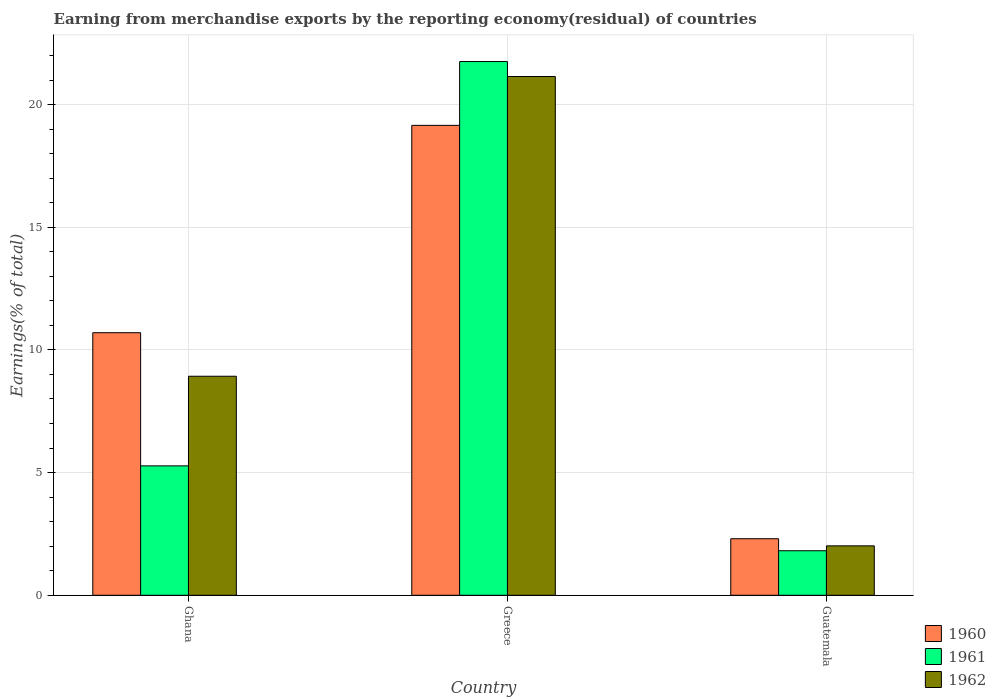How many different coloured bars are there?
Your answer should be very brief. 3. How many groups of bars are there?
Your answer should be compact. 3. Are the number of bars on each tick of the X-axis equal?
Ensure brevity in your answer.  Yes. How many bars are there on the 2nd tick from the left?
Your response must be concise. 3. How many bars are there on the 2nd tick from the right?
Provide a succinct answer. 3. What is the label of the 3rd group of bars from the left?
Your response must be concise. Guatemala. What is the percentage of amount earned from merchandise exports in 1960 in Guatemala?
Keep it short and to the point. 2.3. Across all countries, what is the maximum percentage of amount earned from merchandise exports in 1962?
Offer a very short reply. 21.14. Across all countries, what is the minimum percentage of amount earned from merchandise exports in 1962?
Ensure brevity in your answer.  2.01. In which country was the percentage of amount earned from merchandise exports in 1960 maximum?
Make the answer very short. Greece. In which country was the percentage of amount earned from merchandise exports in 1960 minimum?
Provide a succinct answer. Guatemala. What is the total percentage of amount earned from merchandise exports in 1961 in the graph?
Your response must be concise. 28.84. What is the difference between the percentage of amount earned from merchandise exports in 1961 in Ghana and that in Guatemala?
Give a very brief answer. 3.46. What is the difference between the percentage of amount earned from merchandise exports in 1961 in Ghana and the percentage of amount earned from merchandise exports in 1962 in Guatemala?
Your response must be concise. 3.26. What is the average percentage of amount earned from merchandise exports in 1962 per country?
Provide a short and direct response. 10.7. What is the difference between the percentage of amount earned from merchandise exports of/in 1962 and percentage of amount earned from merchandise exports of/in 1961 in Ghana?
Offer a very short reply. 3.65. In how many countries, is the percentage of amount earned from merchandise exports in 1961 greater than 9 %?
Provide a short and direct response. 1. What is the ratio of the percentage of amount earned from merchandise exports in 1960 in Ghana to that in Guatemala?
Offer a very short reply. 4.64. What is the difference between the highest and the second highest percentage of amount earned from merchandise exports in 1960?
Offer a terse response. -8.45. What is the difference between the highest and the lowest percentage of amount earned from merchandise exports in 1960?
Your answer should be very brief. 16.85. Is the sum of the percentage of amount earned from merchandise exports in 1961 in Ghana and Guatemala greater than the maximum percentage of amount earned from merchandise exports in 1962 across all countries?
Your answer should be very brief. No. What does the 3rd bar from the left in Ghana represents?
Provide a succinct answer. 1962. Is it the case that in every country, the sum of the percentage of amount earned from merchandise exports in 1962 and percentage of amount earned from merchandise exports in 1961 is greater than the percentage of amount earned from merchandise exports in 1960?
Offer a terse response. Yes. How many bars are there?
Your answer should be very brief. 9. What is the difference between two consecutive major ticks on the Y-axis?
Make the answer very short. 5. Are the values on the major ticks of Y-axis written in scientific E-notation?
Provide a succinct answer. No. Does the graph contain any zero values?
Provide a short and direct response. No. Where does the legend appear in the graph?
Provide a succinct answer. Bottom right. What is the title of the graph?
Offer a very short reply. Earning from merchandise exports by the reporting economy(residual) of countries. Does "1992" appear as one of the legend labels in the graph?
Your response must be concise. No. What is the label or title of the Y-axis?
Provide a short and direct response. Earnings(% of total). What is the Earnings(% of total) in 1960 in Ghana?
Keep it short and to the point. 10.7. What is the Earnings(% of total) in 1961 in Ghana?
Make the answer very short. 5.27. What is the Earnings(% of total) in 1962 in Ghana?
Provide a short and direct response. 8.93. What is the Earnings(% of total) of 1960 in Greece?
Provide a short and direct response. 19.15. What is the Earnings(% of total) of 1961 in Greece?
Provide a succinct answer. 21.75. What is the Earnings(% of total) in 1962 in Greece?
Provide a succinct answer. 21.14. What is the Earnings(% of total) in 1960 in Guatemala?
Offer a very short reply. 2.3. What is the Earnings(% of total) of 1961 in Guatemala?
Provide a succinct answer. 1.81. What is the Earnings(% of total) of 1962 in Guatemala?
Ensure brevity in your answer.  2.01. Across all countries, what is the maximum Earnings(% of total) in 1960?
Your response must be concise. 19.15. Across all countries, what is the maximum Earnings(% of total) in 1961?
Give a very brief answer. 21.75. Across all countries, what is the maximum Earnings(% of total) in 1962?
Keep it short and to the point. 21.14. Across all countries, what is the minimum Earnings(% of total) in 1960?
Provide a short and direct response. 2.3. Across all countries, what is the minimum Earnings(% of total) of 1961?
Your answer should be very brief. 1.81. Across all countries, what is the minimum Earnings(% of total) in 1962?
Provide a succinct answer. 2.01. What is the total Earnings(% of total) of 1960 in the graph?
Offer a terse response. 32.16. What is the total Earnings(% of total) in 1961 in the graph?
Offer a terse response. 28.84. What is the total Earnings(% of total) in 1962 in the graph?
Give a very brief answer. 32.09. What is the difference between the Earnings(% of total) of 1960 in Ghana and that in Greece?
Give a very brief answer. -8.45. What is the difference between the Earnings(% of total) in 1961 in Ghana and that in Greece?
Your answer should be very brief. -16.48. What is the difference between the Earnings(% of total) in 1962 in Ghana and that in Greece?
Provide a succinct answer. -12.22. What is the difference between the Earnings(% of total) in 1960 in Ghana and that in Guatemala?
Provide a short and direct response. 8.4. What is the difference between the Earnings(% of total) of 1961 in Ghana and that in Guatemala?
Offer a very short reply. 3.46. What is the difference between the Earnings(% of total) in 1962 in Ghana and that in Guatemala?
Give a very brief answer. 6.91. What is the difference between the Earnings(% of total) in 1960 in Greece and that in Guatemala?
Offer a terse response. 16.85. What is the difference between the Earnings(% of total) of 1961 in Greece and that in Guatemala?
Offer a terse response. 19.94. What is the difference between the Earnings(% of total) in 1962 in Greece and that in Guatemala?
Provide a short and direct response. 19.13. What is the difference between the Earnings(% of total) in 1960 in Ghana and the Earnings(% of total) in 1961 in Greece?
Your response must be concise. -11.05. What is the difference between the Earnings(% of total) of 1960 in Ghana and the Earnings(% of total) of 1962 in Greece?
Offer a very short reply. -10.44. What is the difference between the Earnings(% of total) in 1961 in Ghana and the Earnings(% of total) in 1962 in Greece?
Offer a very short reply. -15.87. What is the difference between the Earnings(% of total) of 1960 in Ghana and the Earnings(% of total) of 1961 in Guatemala?
Your answer should be very brief. 8.89. What is the difference between the Earnings(% of total) of 1960 in Ghana and the Earnings(% of total) of 1962 in Guatemala?
Keep it short and to the point. 8.69. What is the difference between the Earnings(% of total) of 1961 in Ghana and the Earnings(% of total) of 1962 in Guatemala?
Provide a succinct answer. 3.26. What is the difference between the Earnings(% of total) of 1960 in Greece and the Earnings(% of total) of 1961 in Guatemala?
Keep it short and to the point. 17.34. What is the difference between the Earnings(% of total) of 1960 in Greece and the Earnings(% of total) of 1962 in Guatemala?
Your response must be concise. 17.14. What is the difference between the Earnings(% of total) of 1961 in Greece and the Earnings(% of total) of 1962 in Guatemala?
Offer a very short reply. 19.74. What is the average Earnings(% of total) of 1960 per country?
Offer a terse response. 10.72. What is the average Earnings(% of total) of 1961 per country?
Keep it short and to the point. 9.61. What is the average Earnings(% of total) in 1962 per country?
Provide a short and direct response. 10.7. What is the difference between the Earnings(% of total) of 1960 and Earnings(% of total) of 1961 in Ghana?
Make the answer very short. 5.43. What is the difference between the Earnings(% of total) of 1960 and Earnings(% of total) of 1962 in Ghana?
Make the answer very short. 1.77. What is the difference between the Earnings(% of total) in 1961 and Earnings(% of total) in 1962 in Ghana?
Your answer should be compact. -3.65. What is the difference between the Earnings(% of total) in 1960 and Earnings(% of total) in 1961 in Greece?
Give a very brief answer. -2.6. What is the difference between the Earnings(% of total) of 1960 and Earnings(% of total) of 1962 in Greece?
Give a very brief answer. -1.99. What is the difference between the Earnings(% of total) of 1961 and Earnings(% of total) of 1962 in Greece?
Ensure brevity in your answer.  0.61. What is the difference between the Earnings(% of total) in 1960 and Earnings(% of total) in 1961 in Guatemala?
Your response must be concise. 0.49. What is the difference between the Earnings(% of total) of 1960 and Earnings(% of total) of 1962 in Guatemala?
Keep it short and to the point. 0.29. What is the difference between the Earnings(% of total) in 1961 and Earnings(% of total) in 1962 in Guatemala?
Make the answer very short. -0.2. What is the ratio of the Earnings(% of total) in 1960 in Ghana to that in Greece?
Offer a terse response. 0.56. What is the ratio of the Earnings(% of total) of 1961 in Ghana to that in Greece?
Offer a very short reply. 0.24. What is the ratio of the Earnings(% of total) of 1962 in Ghana to that in Greece?
Provide a short and direct response. 0.42. What is the ratio of the Earnings(% of total) in 1960 in Ghana to that in Guatemala?
Make the answer very short. 4.64. What is the ratio of the Earnings(% of total) of 1961 in Ghana to that in Guatemala?
Ensure brevity in your answer.  2.91. What is the ratio of the Earnings(% of total) of 1962 in Ghana to that in Guatemala?
Ensure brevity in your answer.  4.43. What is the ratio of the Earnings(% of total) in 1960 in Greece to that in Guatemala?
Make the answer very short. 8.31. What is the ratio of the Earnings(% of total) of 1961 in Greece to that in Guatemala?
Make the answer very short. 11.99. What is the ratio of the Earnings(% of total) of 1962 in Greece to that in Guatemala?
Your answer should be very brief. 10.49. What is the difference between the highest and the second highest Earnings(% of total) of 1960?
Provide a succinct answer. 8.45. What is the difference between the highest and the second highest Earnings(% of total) in 1961?
Provide a short and direct response. 16.48. What is the difference between the highest and the second highest Earnings(% of total) in 1962?
Keep it short and to the point. 12.22. What is the difference between the highest and the lowest Earnings(% of total) in 1960?
Give a very brief answer. 16.85. What is the difference between the highest and the lowest Earnings(% of total) of 1961?
Your answer should be compact. 19.94. What is the difference between the highest and the lowest Earnings(% of total) in 1962?
Offer a very short reply. 19.13. 